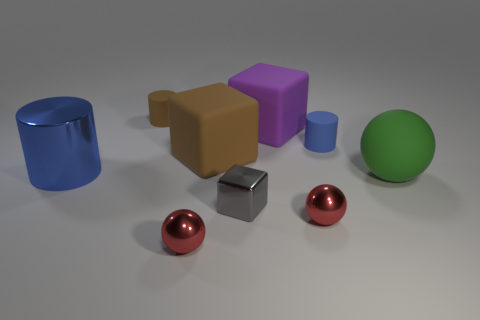Subtract 1 balls. How many balls are left? 2 Add 1 blue metallic cylinders. How many objects exist? 10 Subtract all spheres. How many objects are left? 6 Subtract 0 yellow balls. How many objects are left? 9 Subtract all big cyan metallic cylinders. Subtract all large spheres. How many objects are left? 8 Add 3 matte objects. How many matte objects are left? 8 Add 8 small cyan cylinders. How many small cyan cylinders exist? 8 